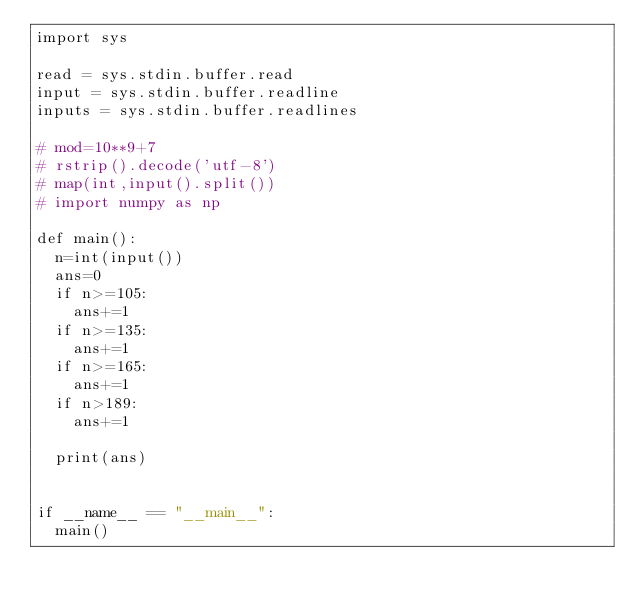<code> <loc_0><loc_0><loc_500><loc_500><_Python_>import sys

read = sys.stdin.buffer.read
input = sys.stdin.buffer.readline
inputs = sys.stdin.buffer.readlines

# mod=10**9+7
# rstrip().decode('utf-8')
# map(int,input().split())
# import numpy as np

def main():
	n=int(input())
	ans=0
	if n>=105:
		ans+=1
	if n>=135:
		ans+=1
	if n>=165:
		ans+=1
	if n>189:
		ans+=1
	
	print(ans)
	
	
if __name__ == "__main__":
	main()
</code> 